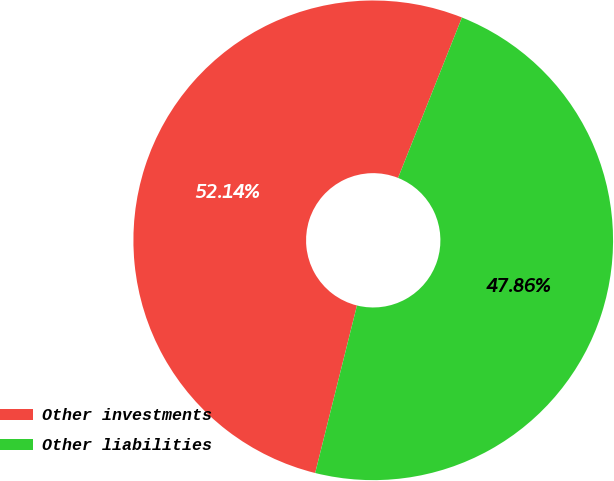Convert chart. <chart><loc_0><loc_0><loc_500><loc_500><pie_chart><fcel>Other investments<fcel>Other liabilities<nl><fcel>52.14%<fcel>47.86%<nl></chart> 